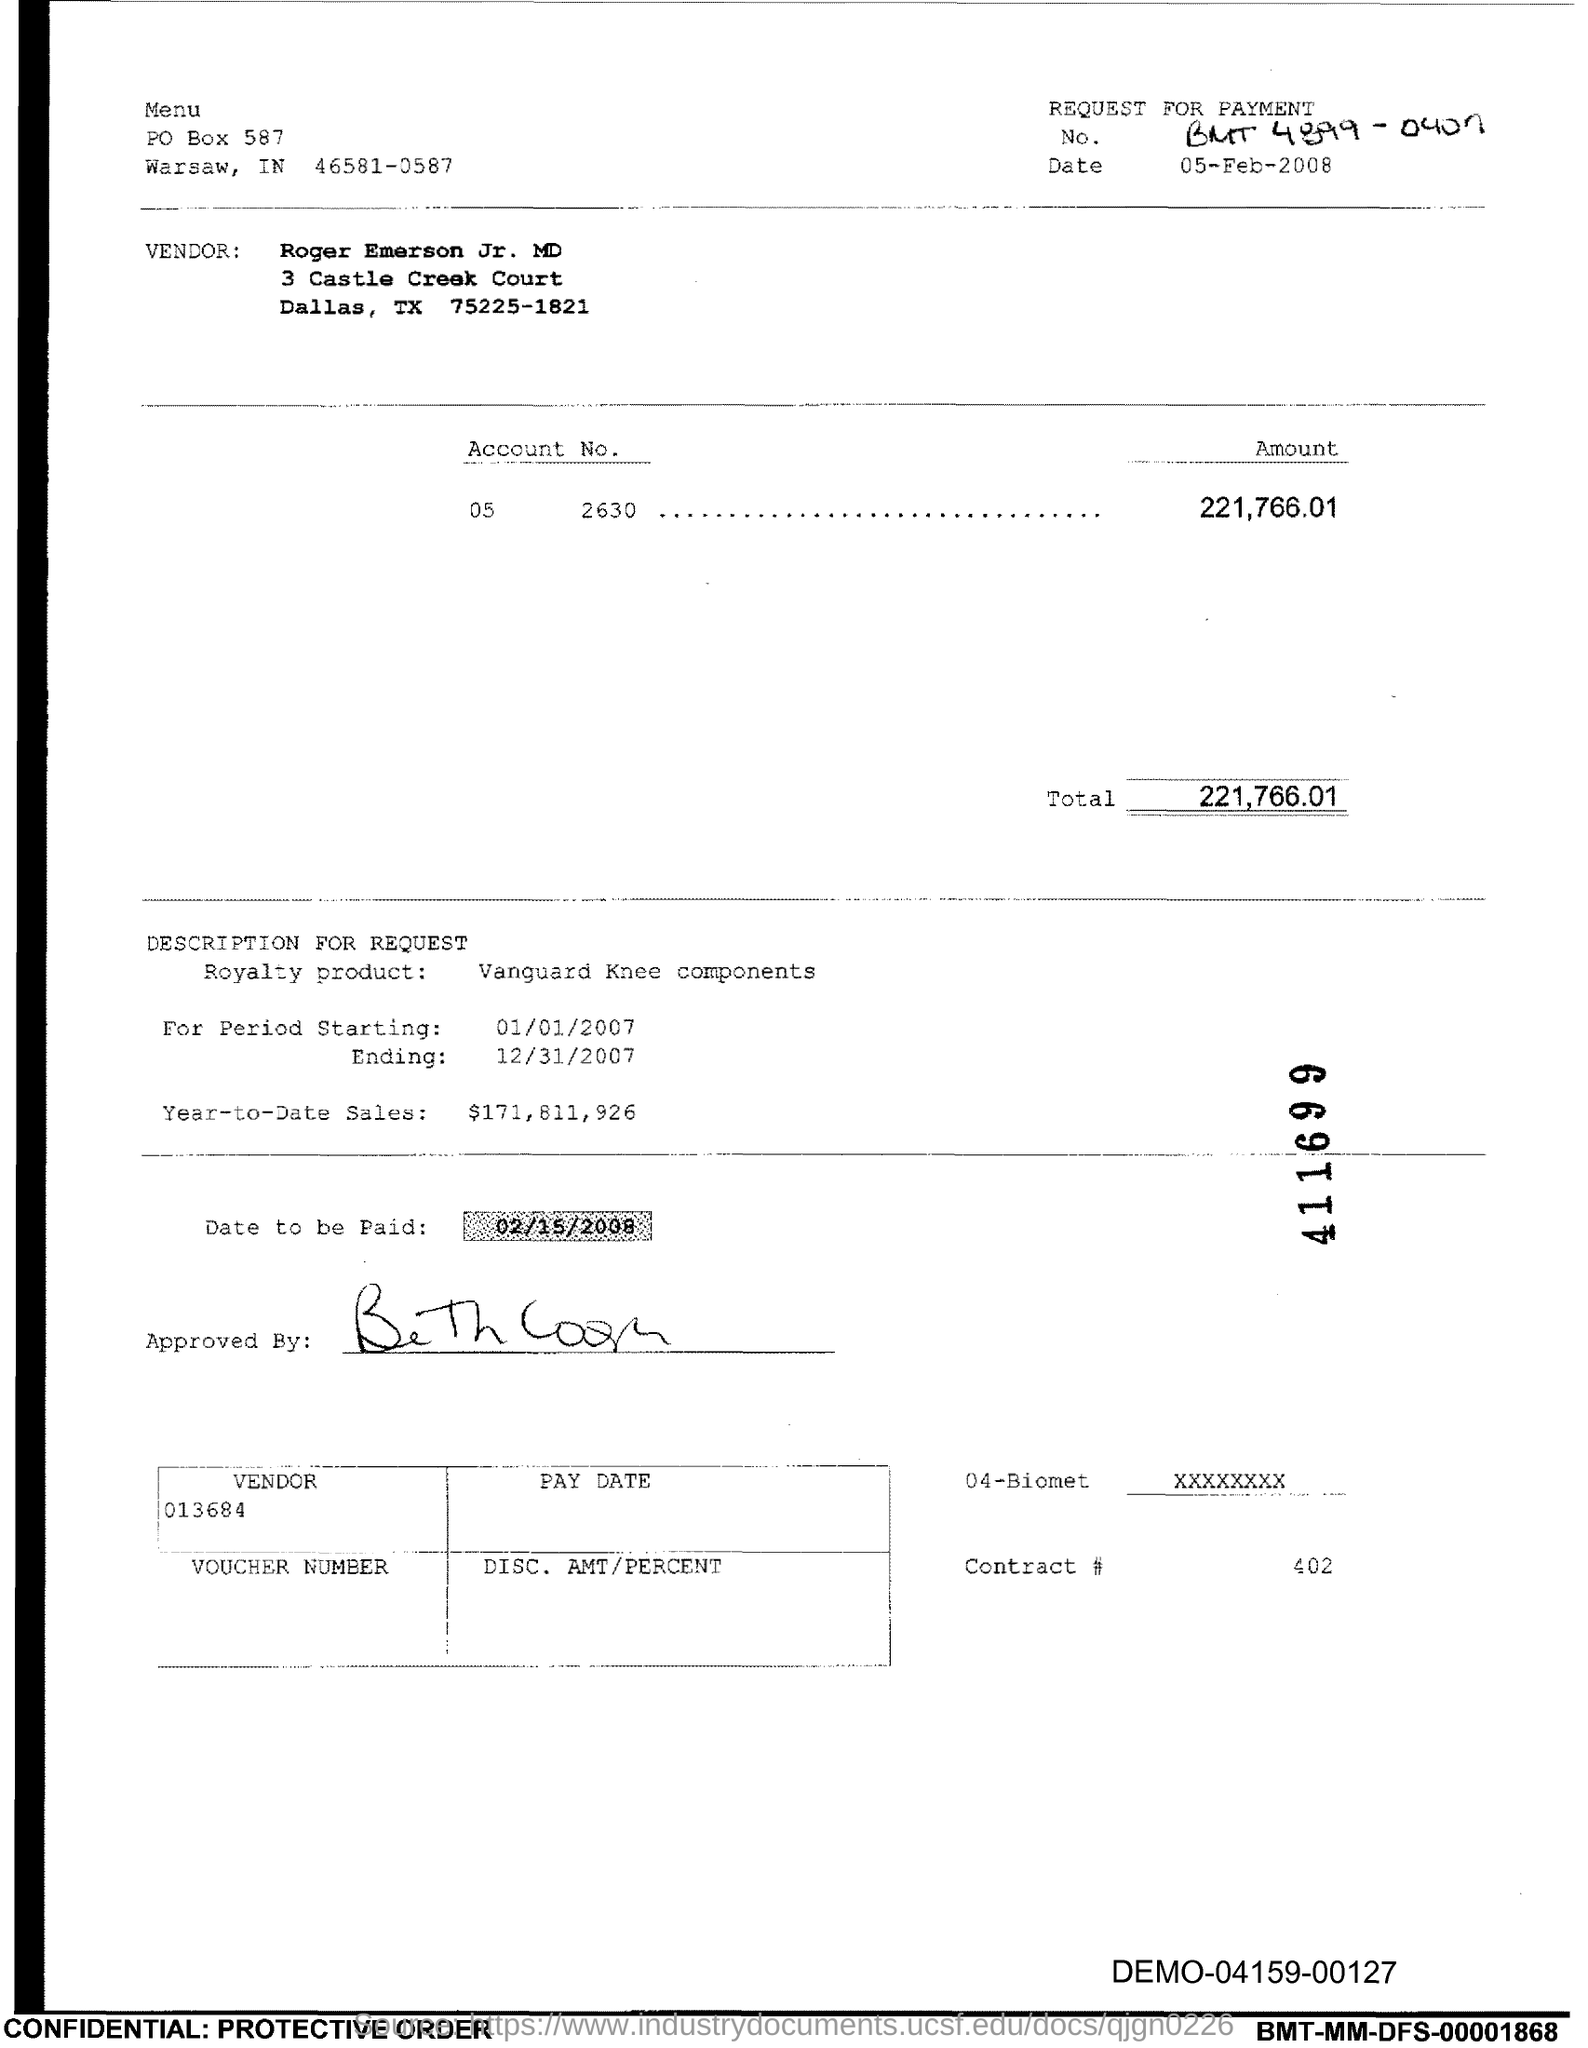What is the Contract # Number?
Provide a short and direct response. 402. What is the Total?
Keep it short and to the point. 221,766.01. 